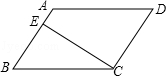Describe the significance of the perpendicular line CE in relation to triangle ABE. The perpendicular line CE in triangle ABE divides the triangle into two right-angled triangles, namely triangle AEC and triangle BEC. This is significant because it allows for the application of right triangle properties and theorems, such as the Pythagorean theorem, to further explore the dimensions and relationships within the triangle. Additionally, it simplifies the calculation of the triangle's area and offers insights into the geometric properties of the parallelogram as a whole. 